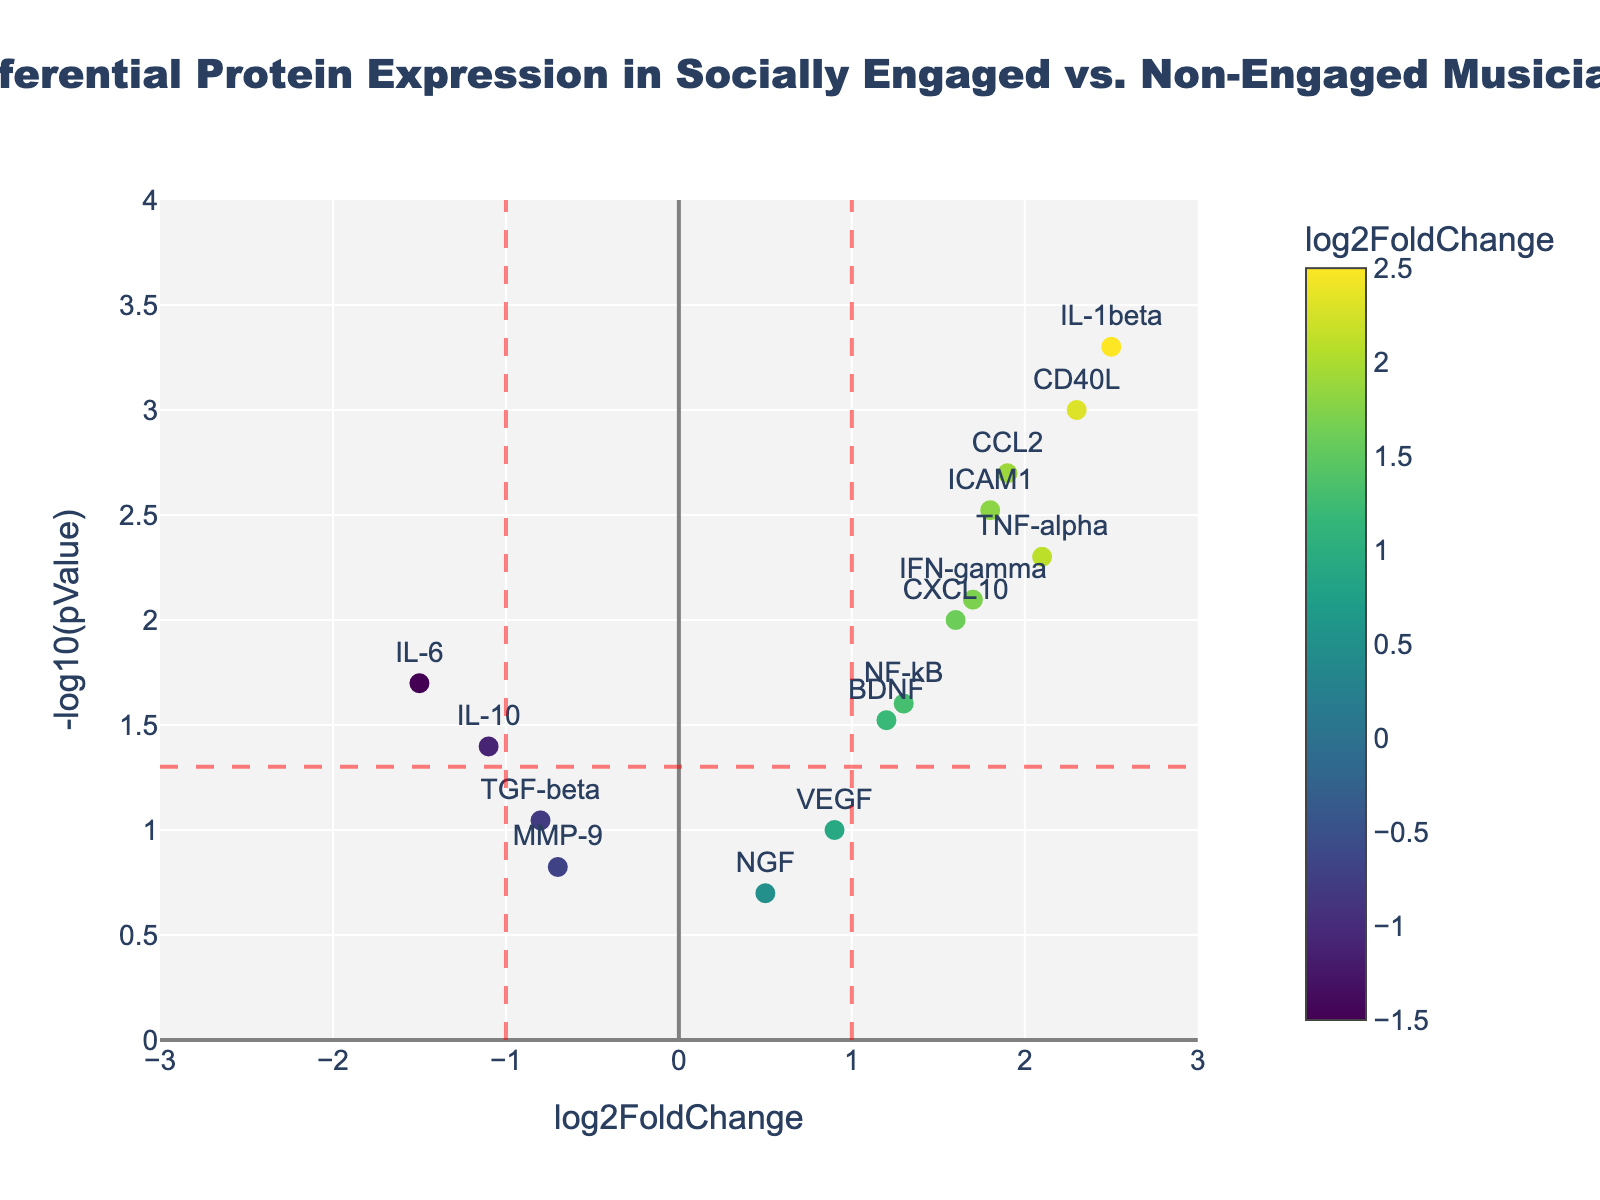what is the title of the plot? The title can be found at the top of the plot, usually in a larger and bolder font.
Answer: Differential Protein Expression in Socially Engaged vs. Non-Engaged Musicians What do the colors of the points represent? The colors of the points are indicated by the color bar on the right side of the plot, which shows that the color represents the log2FoldChange values.
Answer: log2FoldChange values Which protein has the highest -log10(pValue)? The highest -log10(pValue) is the point highest on the y-axis. The protein label for this point is IL-1beta, with an approximate y-axis value of 3.
Answer: IL-1beta How many proteins are shown with a log2FoldChange greater than 1 and -log10(pValue) greater than 1.5? By looking at the points to the right of the vertical line at 1 (positive x-axis) and above the horizontal line at 1.5 (y-axis), we count the number of relevant proteins.
Answer: 4 Which protein exhibits the highest log2FoldChange among those with p-values less than 0.05? Proteins with p-values less than 0.05 are above the y-axis line around 1.3. Among these, find the protein with the highest x-axis value.
Answer: IL-1beta What's the log2FoldChange range of proteins with a significant p-value cut-off of 0.05? Significance at p < 0.05 means the points above the y-axis line at 1.3. Consider the minimum and maximum x-axis values (log2FoldChange) of these points.
Answer: -1.5 to 2.5 Which protein is closest to the threshold lines but not considered significantly changed? The point closest to the dashed red lines (log2FoldChange of ±1 and -log10(pValue) of 1.3) but below the significance line and within the ±1 range on x-axis is considered.
Answer: VEGF What can be inferred about BDNF expression between socially engaged and non-engaged musicians based on the plot? Locate the BDNF data point and observe its position relative to the significance and log2FoldChange lines. BDNF is above the horizontal significance threshold but below ±1 log2FoldChange, indicating a moderate increase.
Answer: Moderate increase 